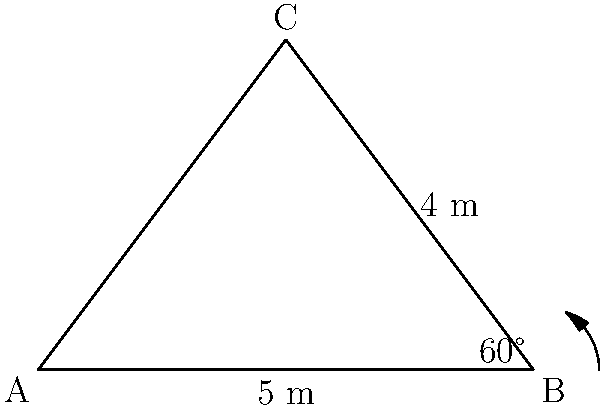As a rookie police officer, you're assisting in securing a triangular park zone for a community event. Given that two sides of the park measure 5 m and 4 m, with an included angle of 60°, calculate the area of the triangular park zone to determine the amount of barricade tape needed. To solve this problem, we'll use the formula for the area of a triangle given two sides and the included angle:

$$A = \frac{1}{2}ab\sin(C)$$

Where:
- $A$ is the area of the triangle
- $a$ and $b$ are the lengths of the two known sides
- $C$ is the included angle

Step 1: Identify the given information
- Side $a = 5$ m
- Side $b = 4$ m
- Angle $C = 60°$

Step 2: Substitute the values into the formula
$$A = \frac{1}{2} \cdot 5 \cdot 4 \cdot \sin(60°)$$

Step 3: Calculate $\sin(60°)$
$\sin(60°) = \frac{\sqrt{3}}{2}$

Step 4: Substitute this value and simplify
$$A = \frac{1}{2} \cdot 5 \cdot 4 \cdot \frac{\sqrt{3}}{2}$$
$$A = 5 \cdot \frac{\sqrt{3}}{2}$$

Step 5: Simplify the final expression
$$A = \frac{5\sqrt{3}}{2} \approx 4.33$$

Therefore, the area of the triangular park zone is approximately 4.33 square meters.
Answer: $\frac{5\sqrt{3}}{2}$ m² or approximately 4.33 m² 